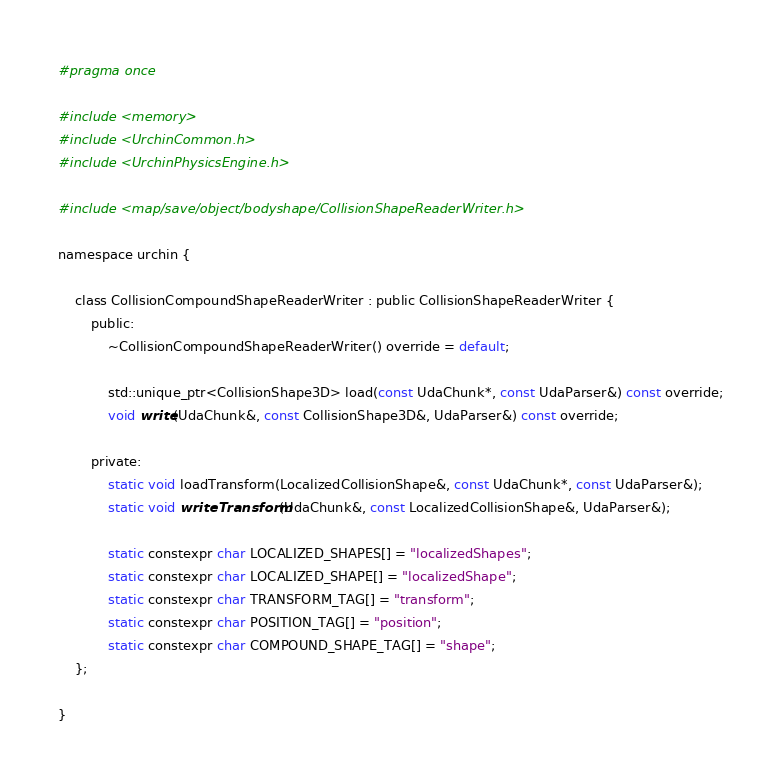<code> <loc_0><loc_0><loc_500><loc_500><_C_>#pragma once

#include <memory>
#include <UrchinCommon.h>
#include <UrchinPhysicsEngine.h>

#include <map/save/object/bodyshape/CollisionShapeReaderWriter.h>

namespace urchin {

    class CollisionCompoundShapeReaderWriter : public CollisionShapeReaderWriter {
        public:
            ~CollisionCompoundShapeReaderWriter() override = default;

            std::unique_ptr<CollisionShape3D> load(const UdaChunk*, const UdaParser&) const override;
            void write(UdaChunk&, const CollisionShape3D&, UdaParser&) const override;

        private:
            static void loadTransform(LocalizedCollisionShape&, const UdaChunk*, const UdaParser&);
            static void writeTransform(UdaChunk&, const LocalizedCollisionShape&, UdaParser&);

            static constexpr char LOCALIZED_SHAPES[] = "localizedShapes";
            static constexpr char LOCALIZED_SHAPE[] = "localizedShape";
            static constexpr char TRANSFORM_TAG[] = "transform";
            static constexpr char POSITION_TAG[] = "position";
            static constexpr char COMPOUND_SHAPE_TAG[] = "shape";
    };

}
</code> 